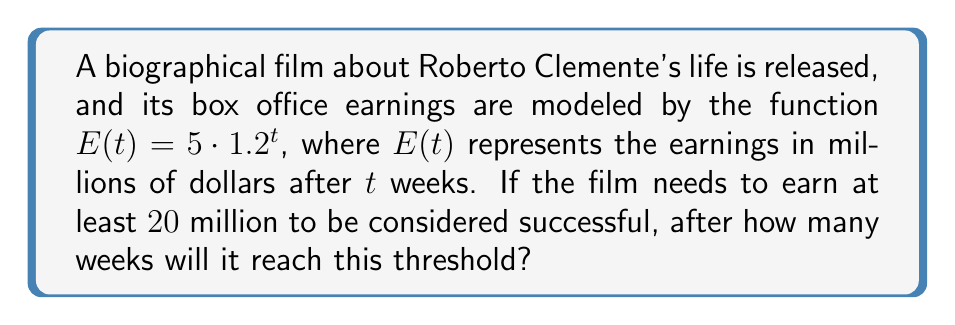Teach me how to tackle this problem. Let's approach this step-by-step:

1) We need to find $t$ when $E(t) = 20$, so we set up the equation:

   $20 = 5 \cdot 1.2^t$

2) Divide both sides by 5:

   $4 = 1.2^t$

3) Take the logarithm of both sides. We can use any base, but let's use base 1.2 for simplicity:

   $\log_{1.2}(4) = \log_{1.2}(1.2^t)$

4) Using the logarithm property $\log_a(a^x) = x$, we get:

   $\log_{1.2}(4) = t$

5) To calculate $\log_{1.2}(4)$, we can use the change of base formula:

   $t = \frac{\ln(4)}{\ln(1.2)}$

6) Using a calculator:

   $t \approx 7.22$

7) Since we can only have whole numbers of weeks, we need to round up to the next integer.

Therefore, the film will reach the $20 million threshold after 8 weeks.
Answer: 8 weeks 